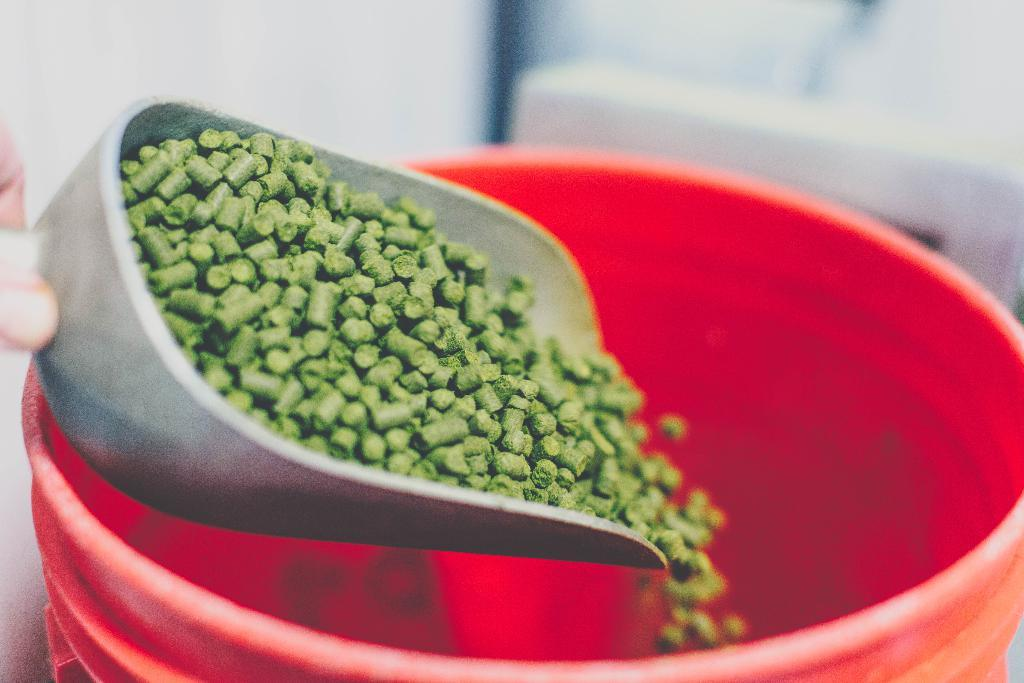Who is present in the image? There is a person in the image. What is the person holding in the image? The person is holding granules in the image. What is the person doing with the granules? The person is pouring the granules into a container in the image. What type of flesh can be seen on the person's hands in the image? There is no flesh visible on the person's hands in the image, as the person is wearing gloves or holding the granules in a way that does not expose their skin. 